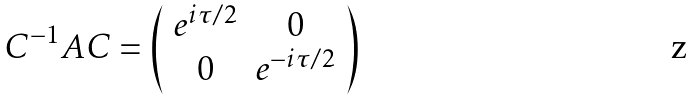Convert formula to latex. <formula><loc_0><loc_0><loc_500><loc_500>C ^ { - 1 } A C = \left ( \begin{array} { c c } e ^ { i \tau / 2 } & 0 \\ 0 & e ^ { - i \tau / 2 } \end{array} \right )</formula> 